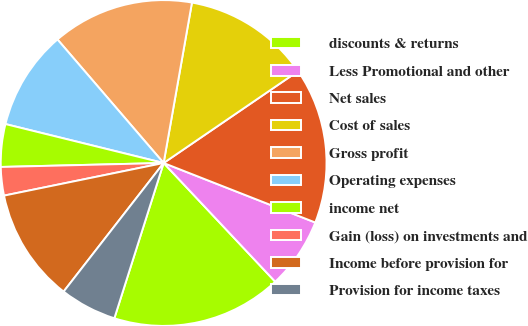Convert chart to OTSL. <chart><loc_0><loc_0><loc_500><loc_500><pie_chart><fcel>discounts & returns<fcel>Less Promotional and other<fcel>Net sales<fcel>Cost of sales<fcel>Gross profit<fcel>Operating expenses<fcel>income net<fcel>Gain (loss) on investments and<fcel>Income before provision for<fcel>Provision for income taxes<nl><fcel>16.9%<fcel>7.04%<fcel>15.49%<fcel>12.68%<fcel>14.08%<fcel>9.86%<fcel>4.23%<fcel>2.82%<fcel>11.27%<fcel>5.63%<nl></chart> 